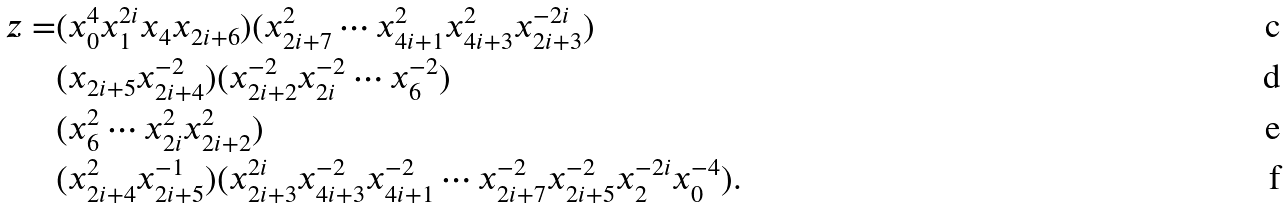<formula> <loc_0><loc_0><loc_500><loc_500>z = & ( x _ { 0 } ^ { 4 } x _ { 1 } ^ { 2 i } x _ { 4 } x _ { 2 i + 6 } ) ( x _ { 2 i + 7 } ^ { 2 } \cdots x _ { 4 i + 1 } ^ { 2 } x _ { 4 i + 3 } ^ { 2 } x _ { 2 i + 3 } ^ { - 2 i } ) \\ & ( x _ { 2 i + 5 } x _ { 2 i + 4 } ^ { - 2 } ) ( x _ { 2 i + 2 } ^ { - 2 } x _ { 2 i } ^ { - 2 } \cdots x _ { 6 } ^ { - 2 } ) \\ & ( x _ { 6 } ^ { 2 } \cdots x _ { 2 i } ^ { 2 } x _ { 2 i + 2 } ^ { 2 } ) \\ & ( x _ { 2 i + 4 } ^ { 2 } x _ { 2 i + 5 } ^ { - 1 } ) ( x _ { 2 i + 3 } ^ { 2 i } x _ { 4 i + 3 } ^ { - 2 } x _ { 4 i + 1 } ^ { - 2 } \cdots x _ { 2 i + 7 } ^ { - 2 } x _ { 2 i + 5 } ^ { - 2 } x _ { 2 } ^ { - 2 i } x _ { 0 } ^ { - 4 } ) .</formula> 